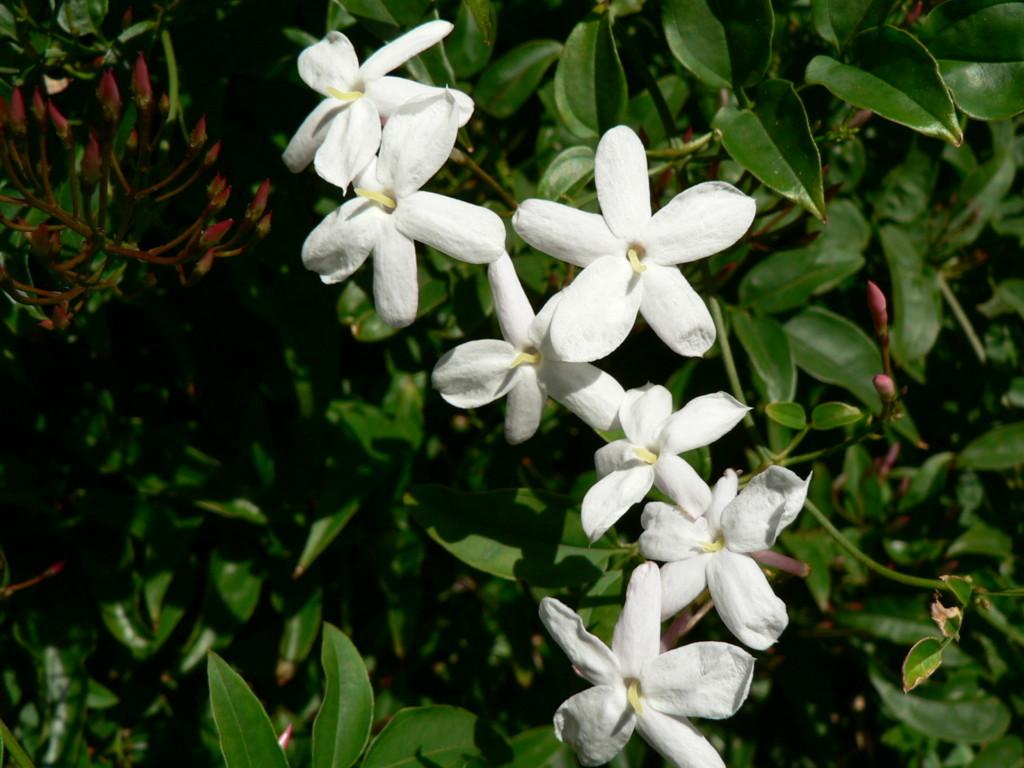What type of plants can be seen in the picture? There are flower plants in the picture. What color are the flowers on the plants? The flowers are white in color. What type of land can be seen in the picture? There is no land visible in the picture; it only features flower plants with white flowers. What does the flower taste like in the picture? The picture is a still image and does not convey taste information. 